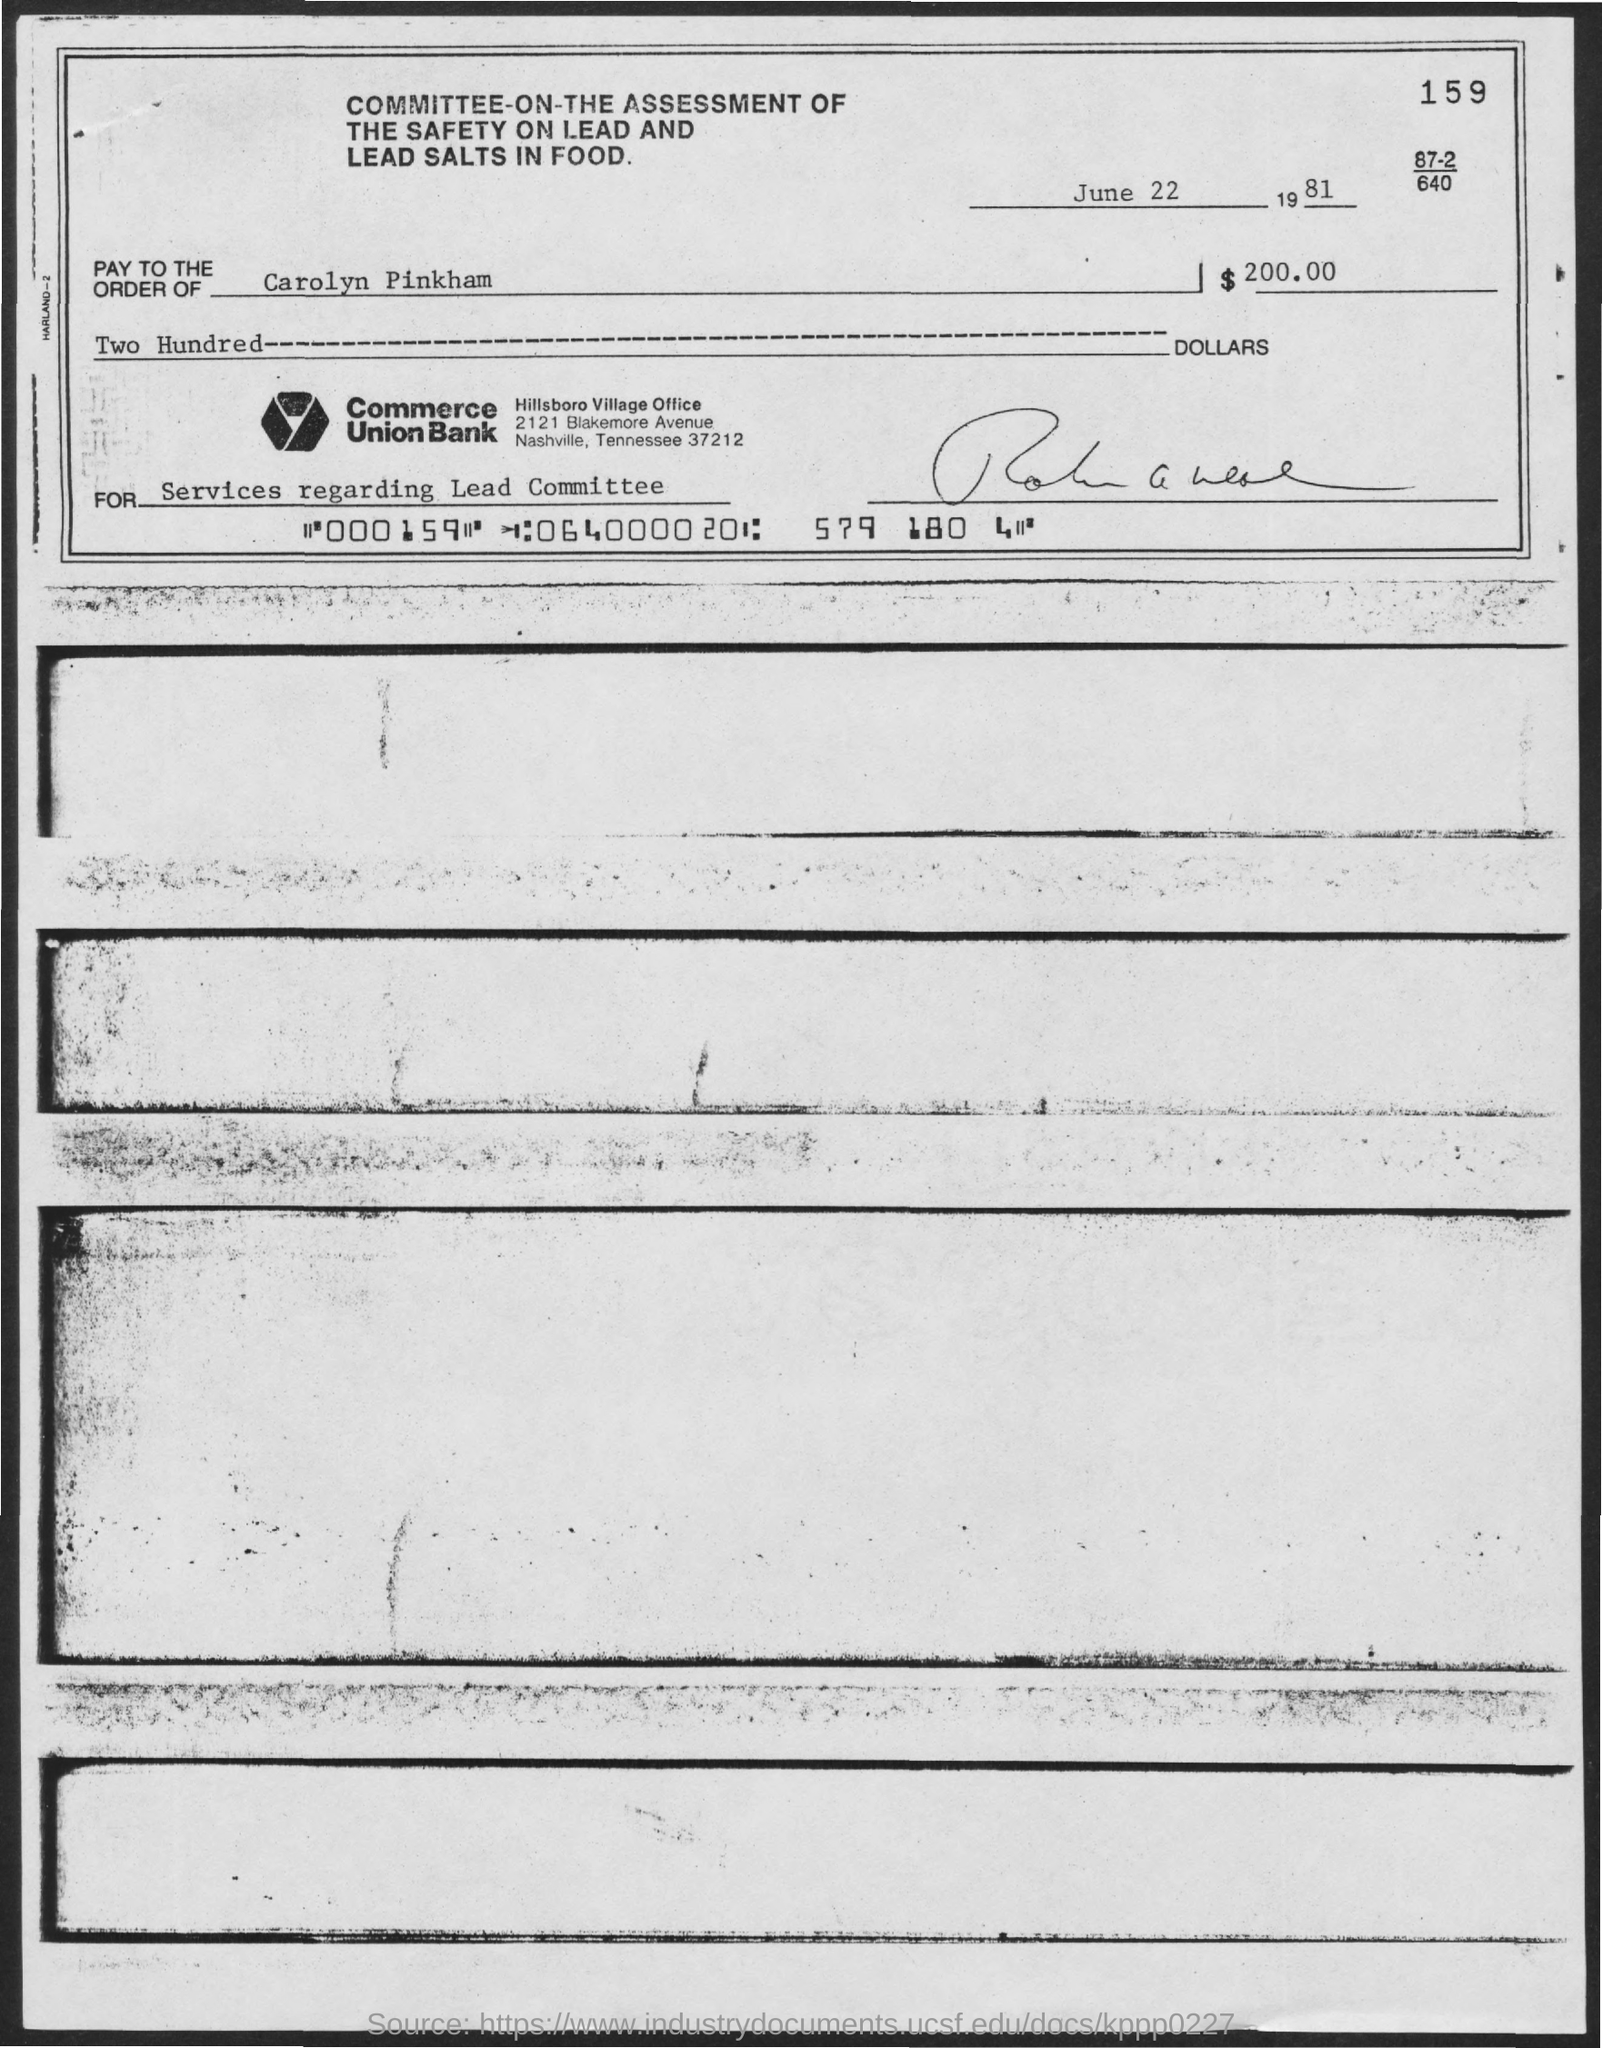Specify some key components in this picture. The amount of the check issued is $200.00. This check was issued by Commerce Union Bank. The check dated June 22, 1981, indicates that it was processed on that specific day. The services offered for the check amount relate to the Lead Committee. 